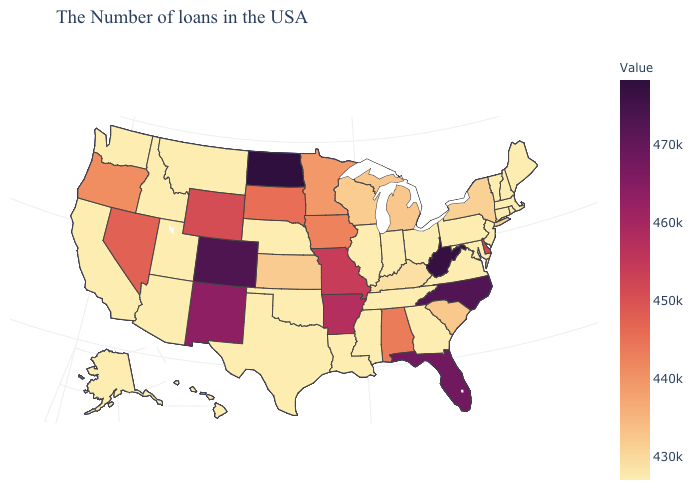Among the states that border Connecticut , does New York have the lowest value?
Quick response, please. No. Among the states that border Wyoming , which have the lowest value?
Be succinct. Nebraska, Utah, Montana, Idaho. Which states have the highest value in the USA?
Short answer required. North Dakota. Does Wyoming have a higher value than Kentucky?
Write a very short answer. Yes. Which states have the lowest value in the Northeast?
Write a very short answer. Maine, Massachusetts, Rhode Island, New Hampshire, Vermont, Connecticut, New Jersey, Pennsylvania. Is the legend a continuous bar?
Write a very short answer. Yes. Is the legend a continuous bar?
Write a very short answer. Yes. 